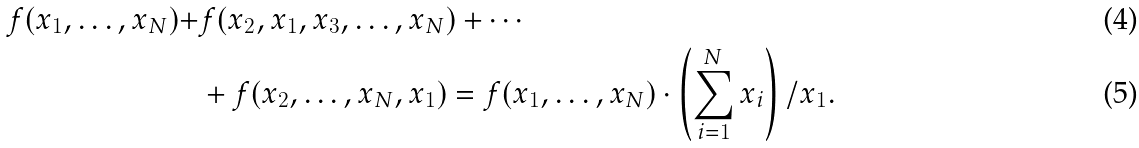Convert formula to latex. <formula><loc_0><loc_0><loc_500><loc_500>f ( x _ { 1 } , \dots , x _ { N } ) + & f ( x _ { 2 } , x _ { 1 } , x _ { 3 } , \dots , x _ { N } ) + \cdots \\ & + f ( x _ { 2 } , \dots , x _ { N } , x _ { 1 } ) = f ( x _ { 1 } , \dots , x _ { N } ) \cdot \left ( \sum _ { i = 1 } ^ { N } x _ { i } \right ) / x _ { 1 } .</formula> 